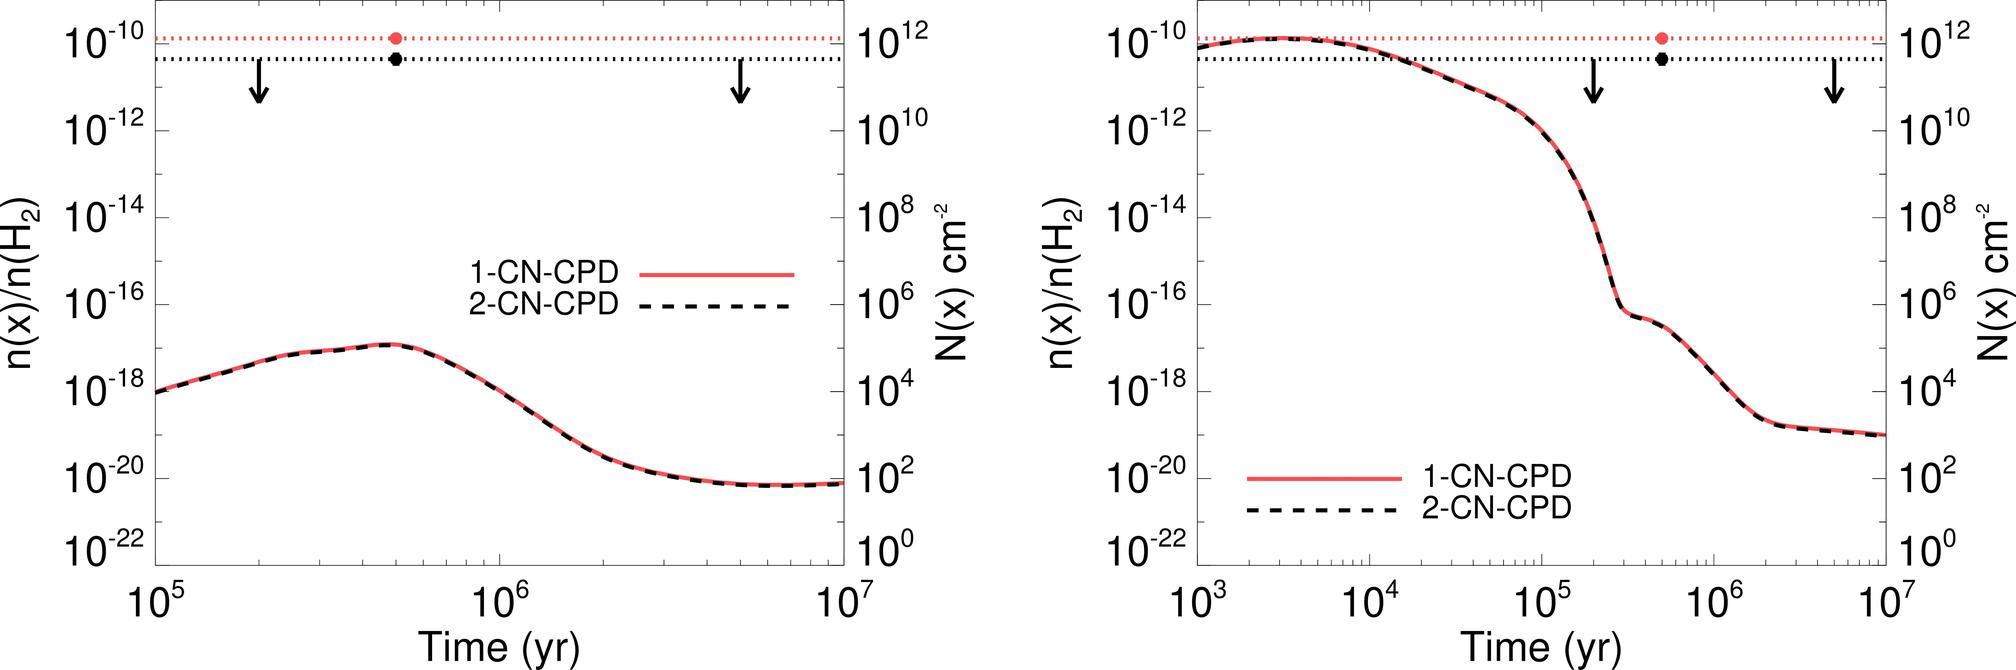Can you explain the significance of the arrows pointing downward on the graphs? The arrows likely represent critical points or phase transitions in the behavior of the 1-CN-CPD and 2-CN-CPD concentrations over time. These points may indicate the start of a rapid decrease in concentration, suggesting a significant change in the underlying processes affecting these compounds. 